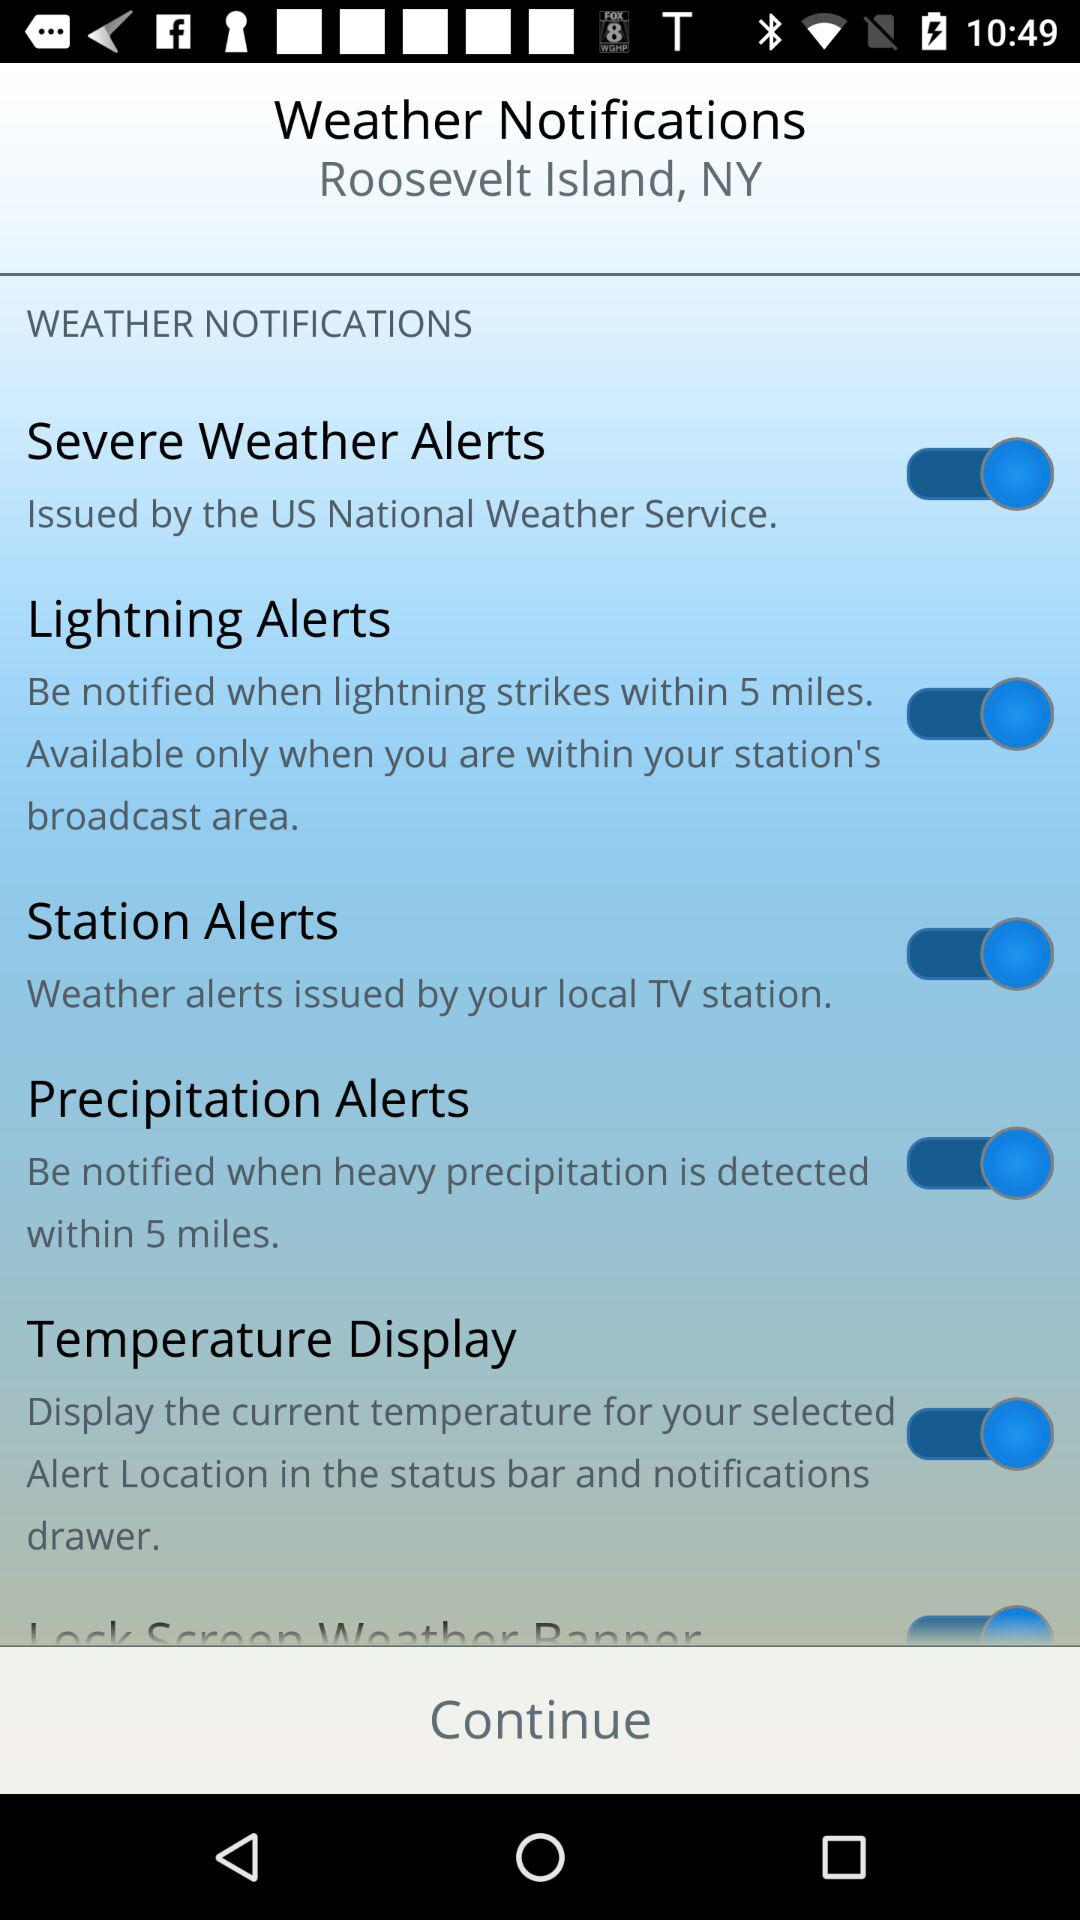What is the name of the island? The name of the island is Roosevelt Island. 